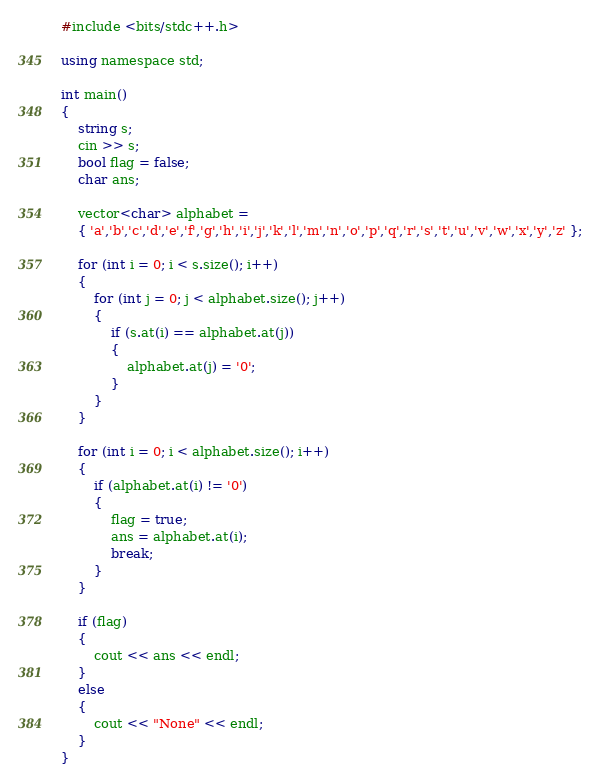<code> <loc_0><loc_0><loc_500><loc_500><_C#_>#include <bits/stdc++.h>

using namespace std;

int main()
{
	string s;
	cin >> s;
	bool flag = false;
	char ans;

	vector<char> alphabet =
	{ 'a','b','c','d','e','f','g','h','i','j','k','l','m','n','o','p','q','r','s','t','u','v','w','x','y','z' };

	for (int i = 0; i < s.size(); i++)
	{
		for (int j = 0; j < alphabet.size(); j++)
		{
			if (s.at(i) == alphabet.at(j))
			{
				alphabet.at(j) = '0';
			}
		}
	}

	for (int i = 0; i < alphabet.size(); i++)
	{
		if (alphabet.at(i) != '0')
		{
			flag = true;
			ans = alphabet.at(i);
			break;
		}
	}

	if (flag)
	{
		cout << ans << endl;
	}
	else
	{
		cout << "None" << endl;
	}
}
</code> 